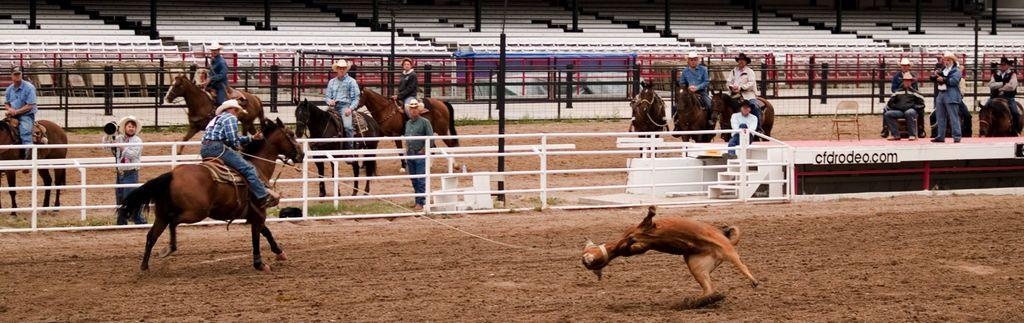Can you describe this image briefly? In this picture there is a man who is riding a horse and he is holding a rope which is the connected to this dog. In the back I can see many people were sitting on the horse. On the left there is a man who is holding a camera and he is standing near to the fencing. At the top I can see the stairs and benches. 